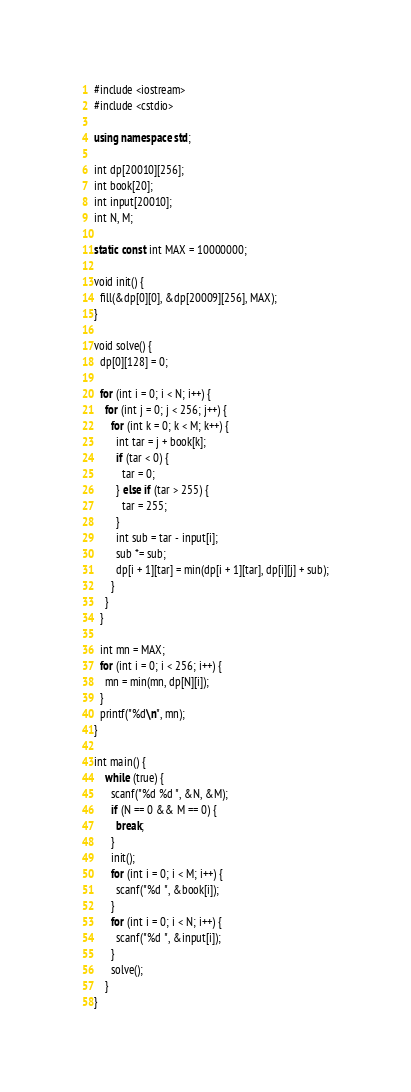<code> <loc_0><loc_0><loc_500><loc_500><_C++_>#include <iostream>
#include <cstdio>

using namespace std;

int dp[20010][256];
int book[20];
int input[20010];
int N, M;

static const int MAX = 10000000;

void init() {
  fill(&dp[0][0], &dp[20009][256], MAX);
}

void solve() {
  dp[0][128] = 0;

  for (int i = 0; i < N; i++) {
    for (int j = 0; j < 256; j++) {
      for (int k = 0; k < M; k++) {
        int tar = j + book[k];
        if (tar < 0) {
          tar = 0;
        } else if (tar > 255) {
          tar = 255;
        }
        int sub = tar - input[i];
        sub *= sub;
        dp[i + 1][tar] = min(dp[i + 1][tar], dp[i][j] + sub);
      }
    }
  }

  int mn = MAX;
  for (int i = 0; i < 256; i++) {
    mn = min(mn, dp[N][i]);
  }
  printf("%d\n", mn);
}

int main() {
    while (true) {
      scanf("%d %d ", &N, &M);
      if (N == 0 && M == 0) {
        break;
      }
      init();
      for (int i = 0; i < M; i++) {
        scanf("%d ", &book[i]);
      }
      for (int i = 0; i < N; i++) {
        scanf("%d ", &input[i]);
      }
      solve();
    }
}</code> 